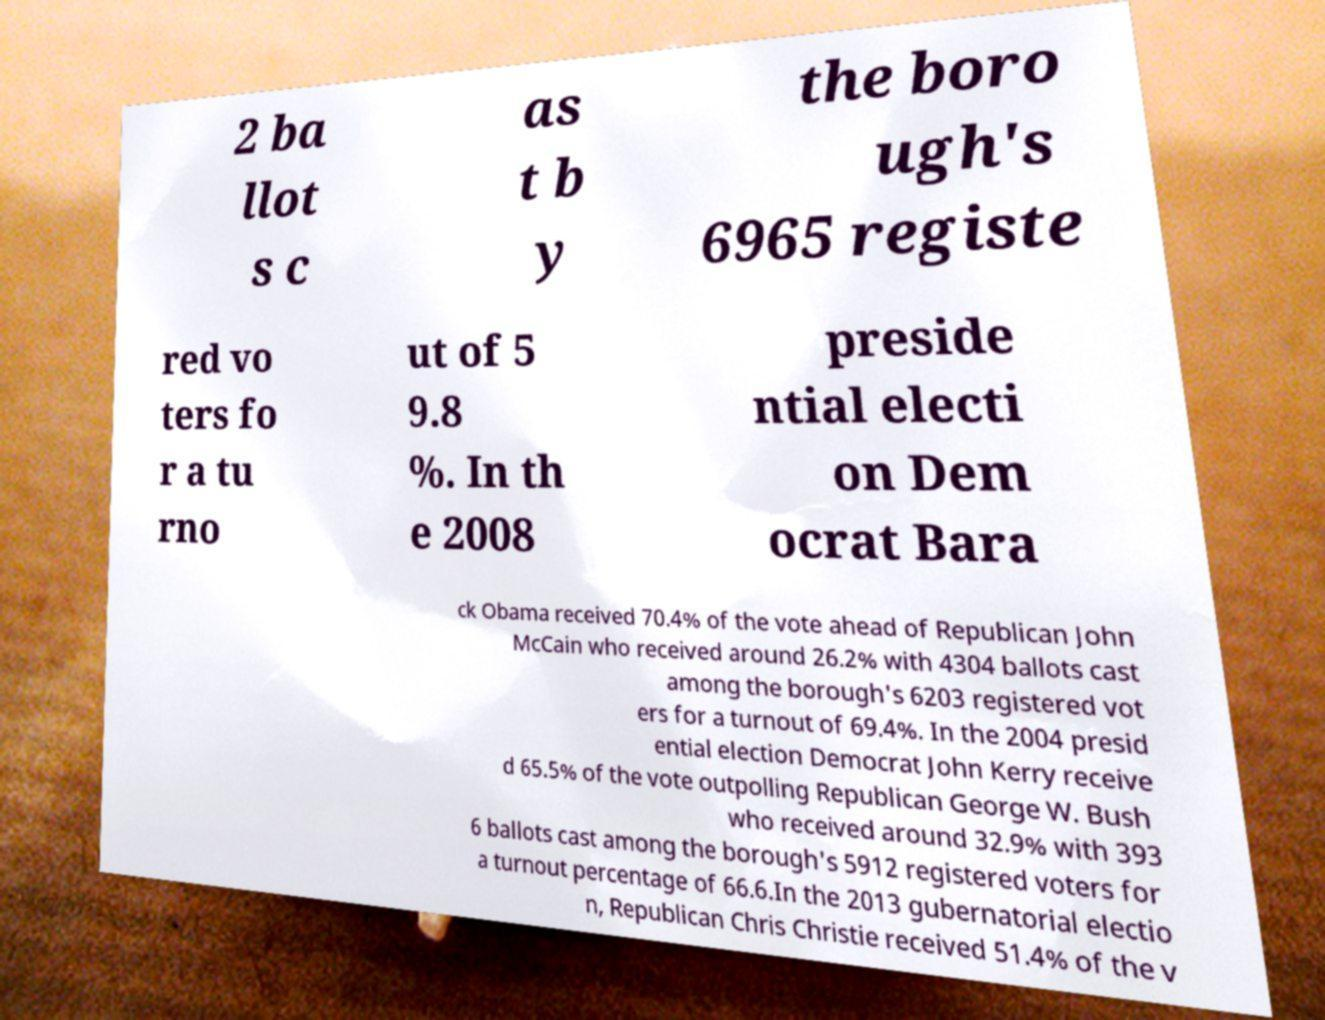Please read and relay the text visible in this image. What does it say? 2 ba llot s c as t b y the boro ugh's 6965 registe red vo ters fo r a tu rno ut of 5 9.8 %. In th e 2008 preside ntial electi on Dem ocrat Bara ck Obama received 70.4% of the vote ahead of Republican John McCain who received around 26.2% with 4304 ballots cast among the borough's 6203 registered vot ers for a turnout of 69.4%. In the 2004 presid ential election Democrat John Kerry receive d 65.5% of the vote outpolling Republican George W. Bush who received around 32.9% with 393 6 ballots cast among the borough's 5912 registered voters for a turnout percentage of 66.6.In the 2013 gubernatorial electio n, Republican Chris Christie received 51.4% of the v 